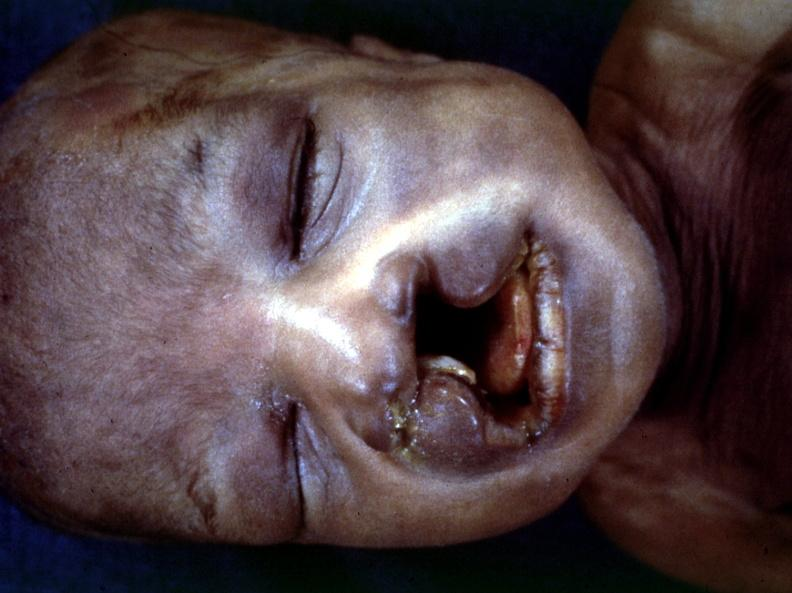what is present?
Answer the question using a single word or phrase. Bilateral cleft palate 